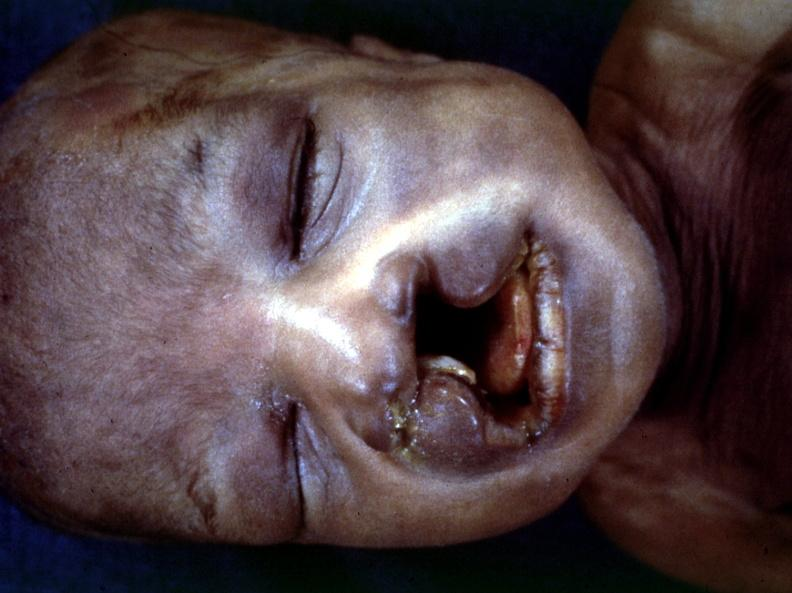what is present?
Answer the question using a single word or phrase. Bilateral cleft palate 